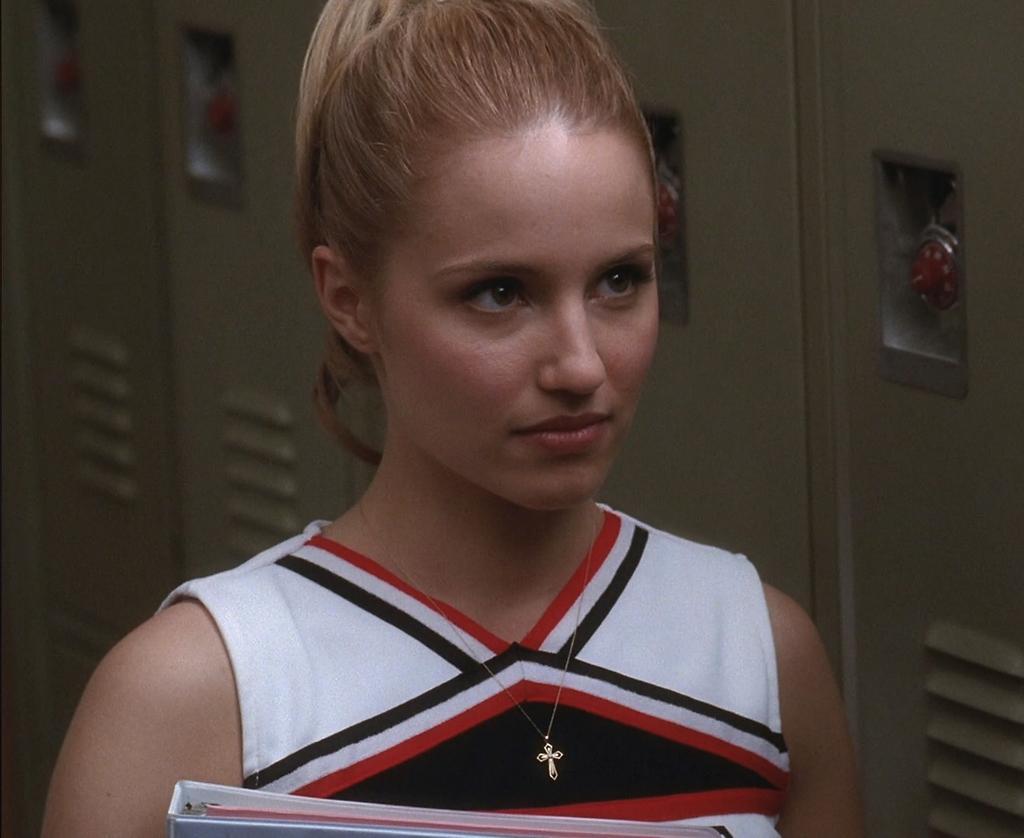How would you summarize this image in a sentence or two? In this image I can see a woman wearing white, black and red colored dress is holding a file in her hand. In the background I can see few lockers. 